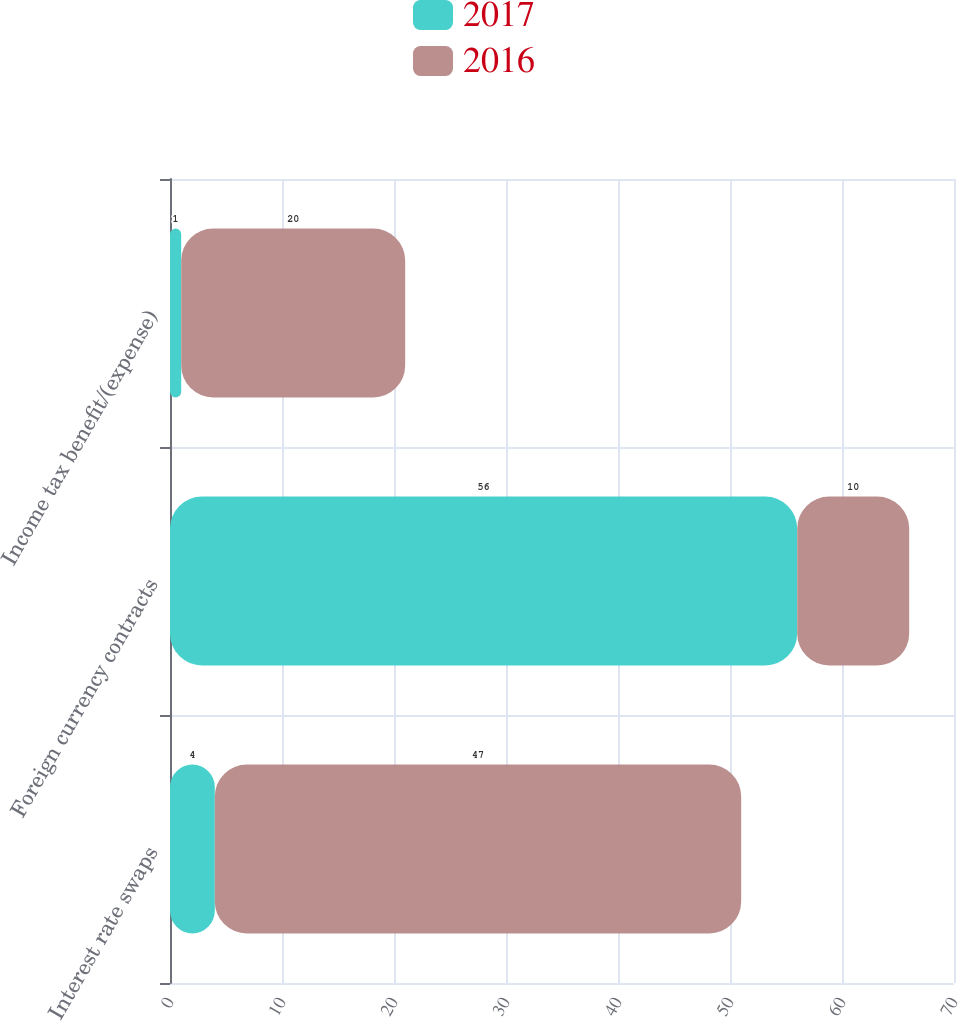Convert chart. <chart><loc_0><loc_0><loc_500><loc_500><stacked_bar_chart><ecel><fcel>Interest rate swaps<fcel>Foreign currency contracts<fcel>Income tax benefit/(expense)<nl><fcel>2017<fcel>4<fcel>56<fcel>1<nl><fcel>2016<fcel>47<fcel>10<fcel>20<nl></chart> 